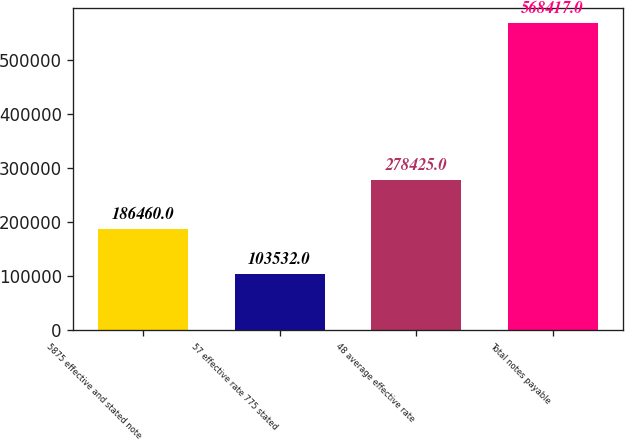Convert chart to OTSL. <chart><loc_0><loc_0><loc_500><loc_500><bar_chart><fcel>5875 effective and stated note<fcel>57 effective rate 775 stated<fcel>48 average effective rate<fcel>Total notes payable<nl><fcel>186460<fcel>103532<fcel>278425<fcel>568417<nl></chart> 